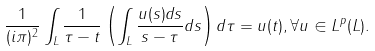Convert formula to latex. <formula><loc_0><loc_0><loc_500><loc_500>\frac { 1 } { ( i \pi ) ^ { 2 } } \int _ { L } \frac { 1 } { \tau - t } \left ( \int _ { L } \frac { u ( s ) d s } { s - \tau } d s \right ) d \tau = u ( t ) , \forall u \in L ^ { p } ( L ) .</formula> 